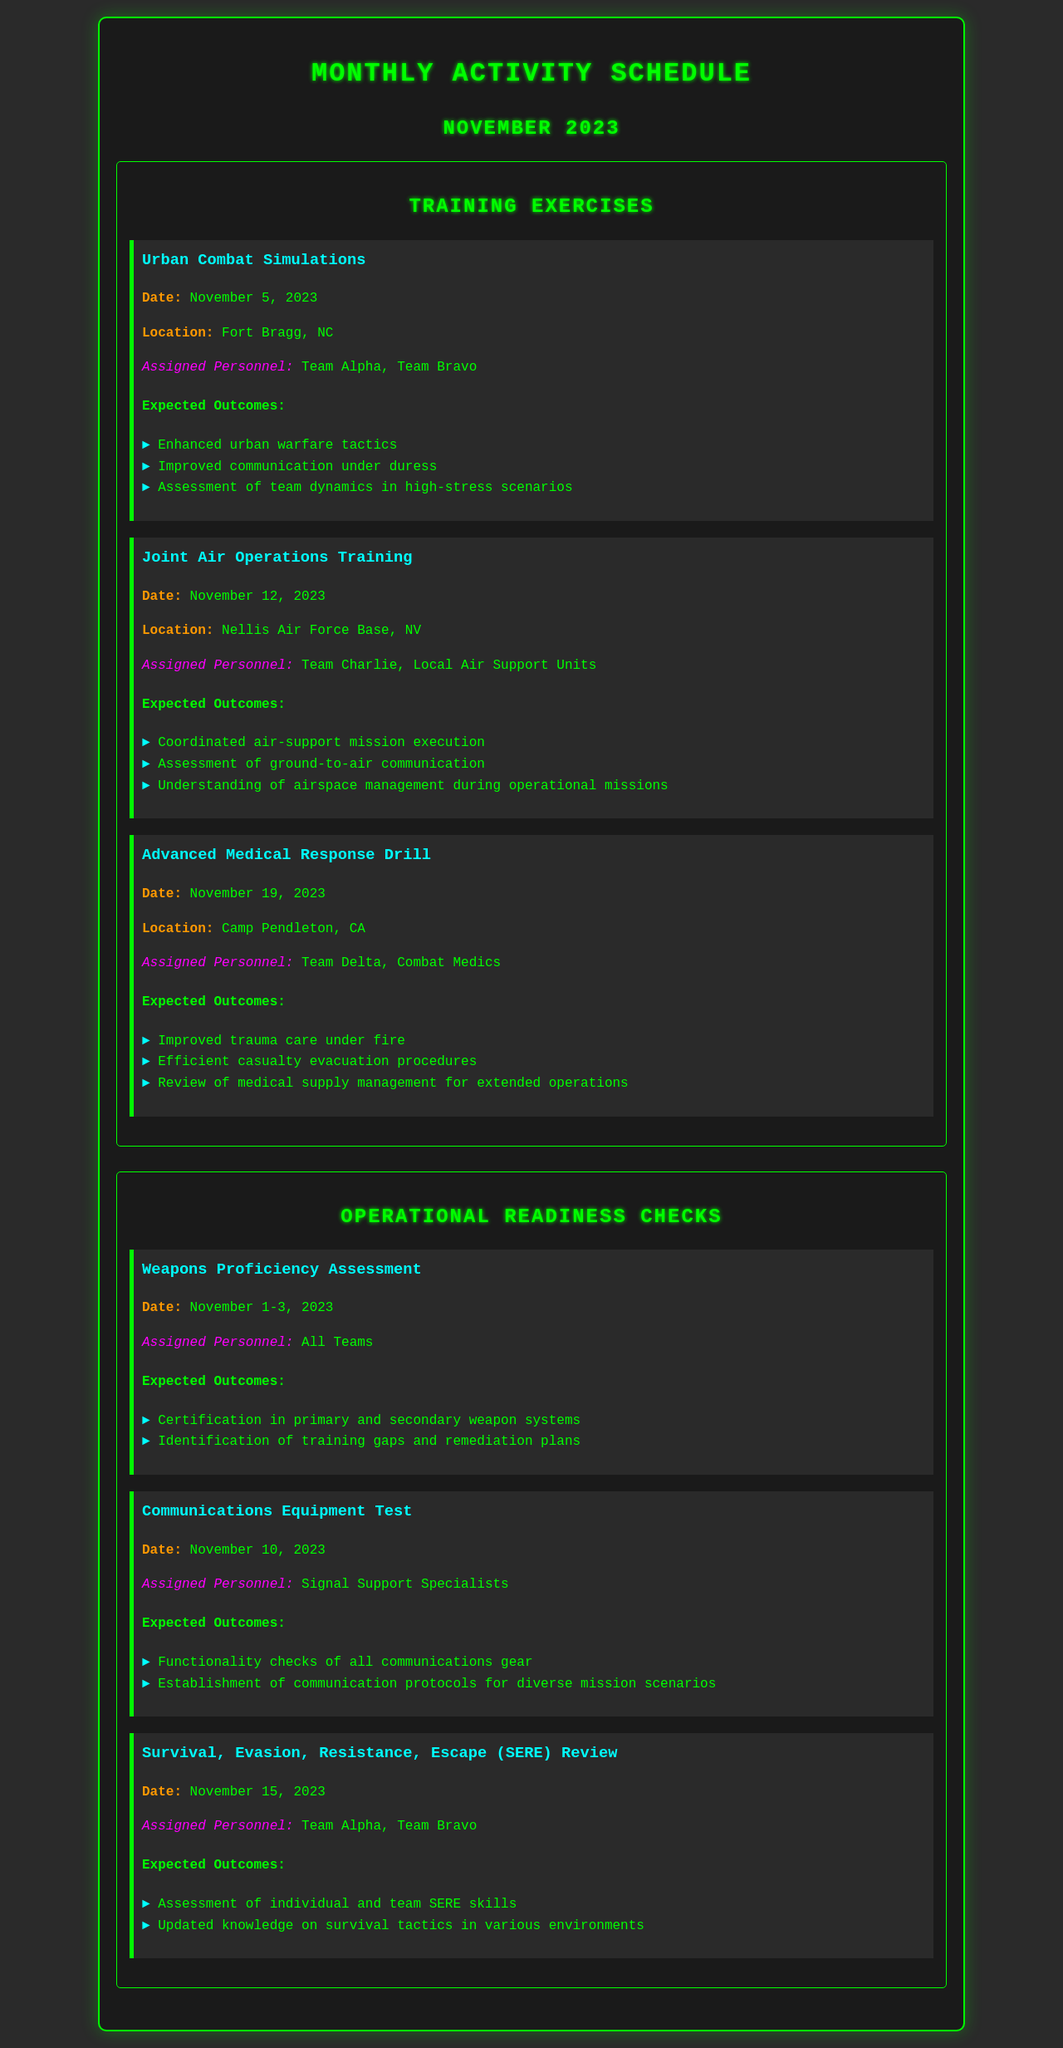What is the date for the Urban Combat Simulations? The document specifies that the Urban Combat Simulations are scheduled for November 5, 2023.
Answer: November 5, 2023 Which teams are assigned to the Advanced Medical Response Drill? The document lists Team Delta and Combat Medics as the personnel assigned to the Advanced Medical Response Drill.
Answer: Team Delta, Combat Medics What is one expected outcome of the Weapons Proficiency Assessment? According to the document, one expected outcome is certification in primary and secondary weapon systems.
Answer: Certification in primary and secondary weapon systems On what date is the Communications Equipment Test scheduled? The document indicates that the Communications Equipment Test is scheduled for November 10, 2023.
Answer: November 10, 2023 Which location hosts the Joint Air Operations Training? The document states that the Joint Air Operations Training takes place at Nellis Air Force Base, NV.
Answer: Nellis Air Force Base, NV What is the primary focus of the Survival, Evasion, Resistance, Escape (SERE) Review? The document mentions that the focus is on assessing individual and team SERE skills.
Answer: Assessing individual and team SERE skills How many days does the Weapons Proficiency Assessment last? The document notes that the Weapons Proficiency Assessment lasts for three days, from November 1 to 3, 2023.
Answer: Three days What is an expected outcome of the Advanced Medical Response Drill? The document lists improved trauma care under fire as an expected outcome of the Advanced Medical Response Drill.
Answer: Improved trauma care under fire Which teams are involved in the Urban Combat Simulations? The document specifies that Team Alpha and Team Bravo are the teams involved in the Urban Combat Simulations.
Answer: Team Alpha, Team Bravo 